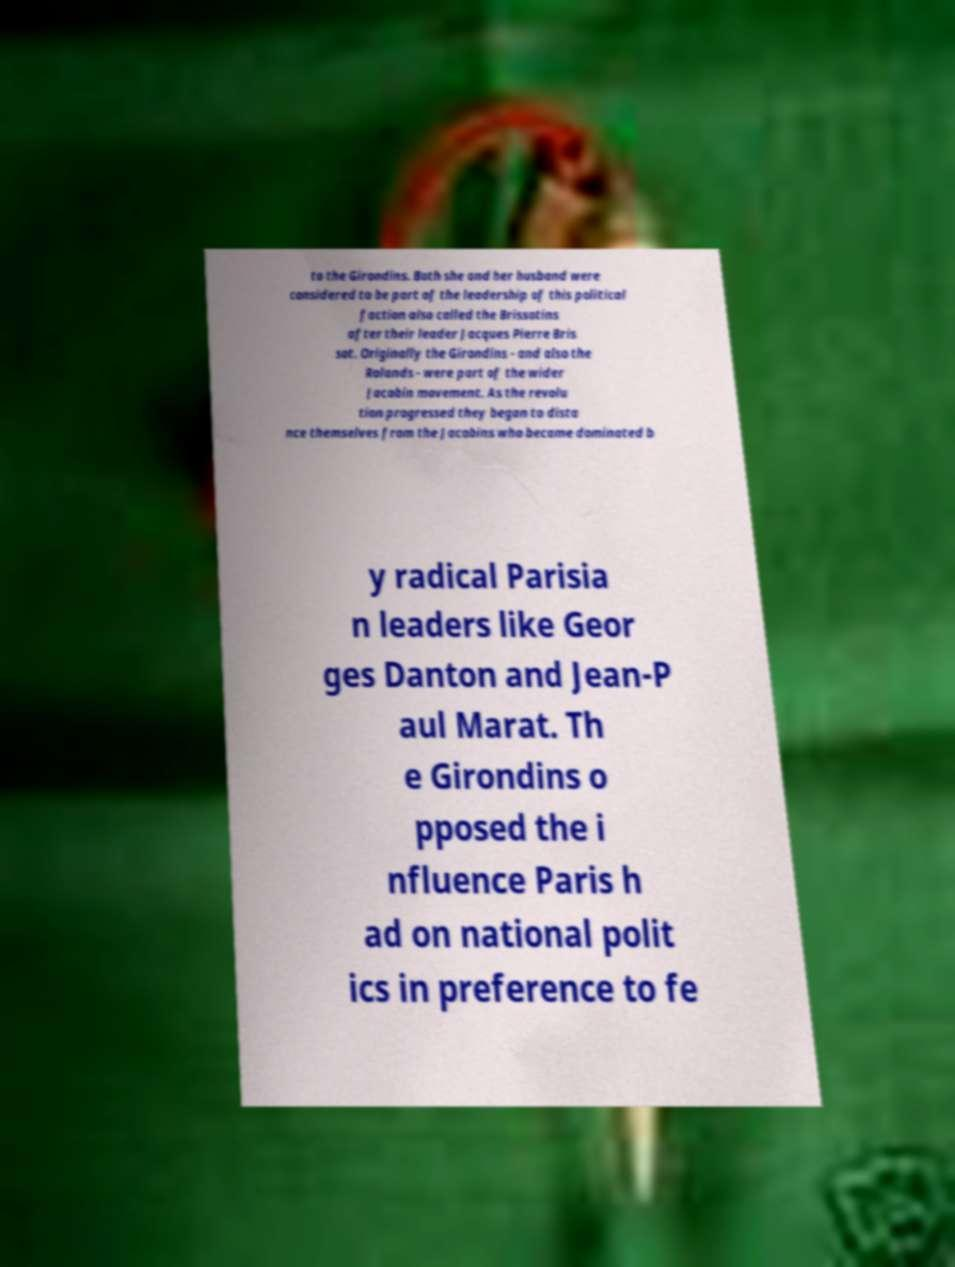Can you accurately transcribe the text from the provided image for me? to the Girondins. Both she and her husband were considered to be part of the leadership of this political faction also called the Brissotins after their leader Jacques Pierre Bris sot. Originally the Girondins - and also the Rolands - were part of the wider Jacobin movement. As the revolu tion progressed they began to dista nce themselves from the Jacobins who became dominated b y radical Parisia n leaders like Geor ges Danton and Jean-P aul Marat. Th e Girondins o pposed the i nfluence Paris h ad on national polit ics in preference to fe 